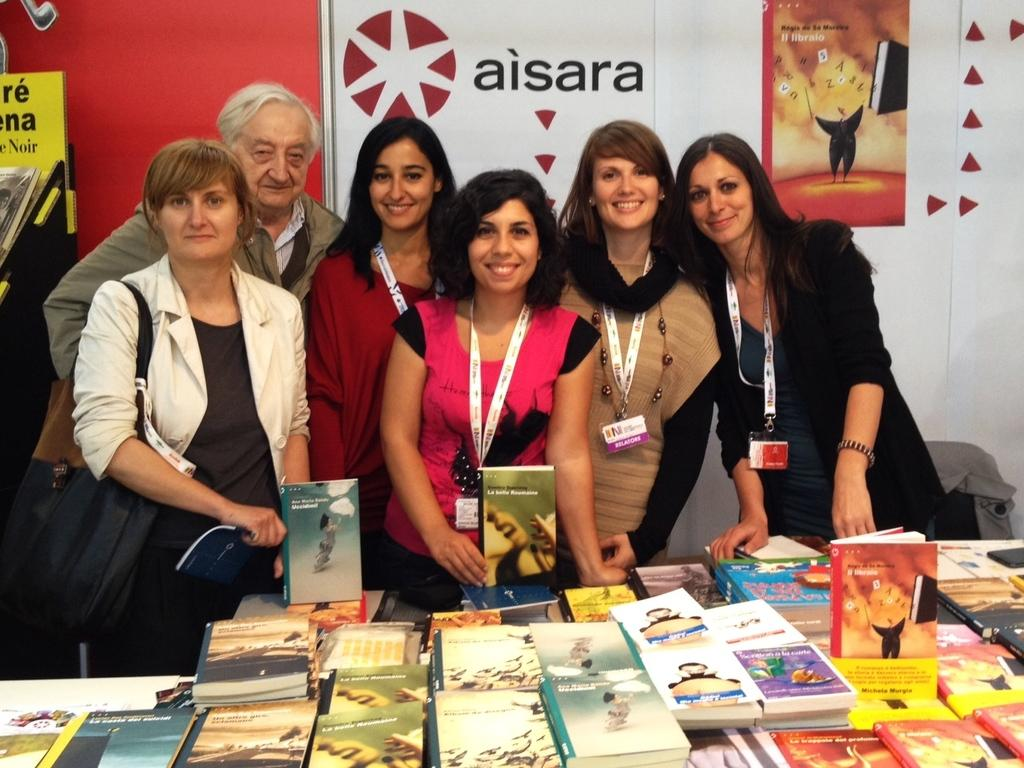Provide a one-sentence caption for the provided image. A small group of people pose in front of an Aisara poster. 